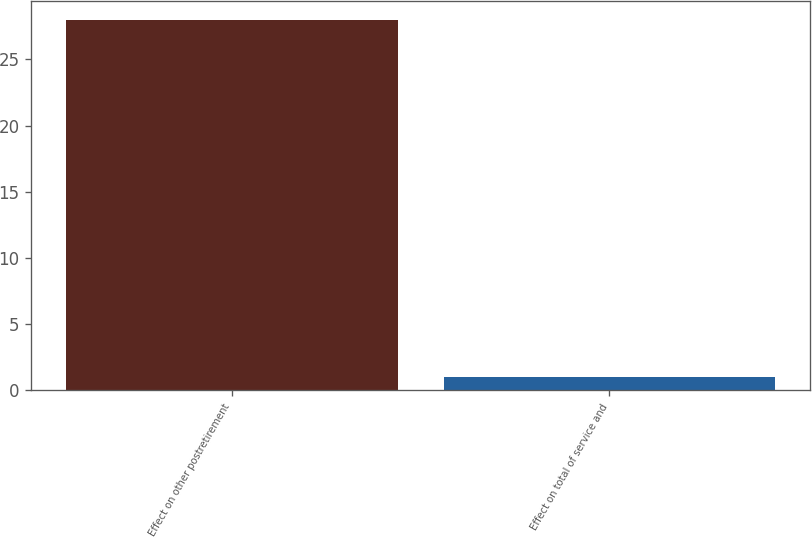<chart> <loc_0><loc_0><loc_500><loc_500><bar_chart><fcel>Effect on other postretirement<fcel>Effect on total of service and<nl><fcel>28<fcel>1<nl></chart> 